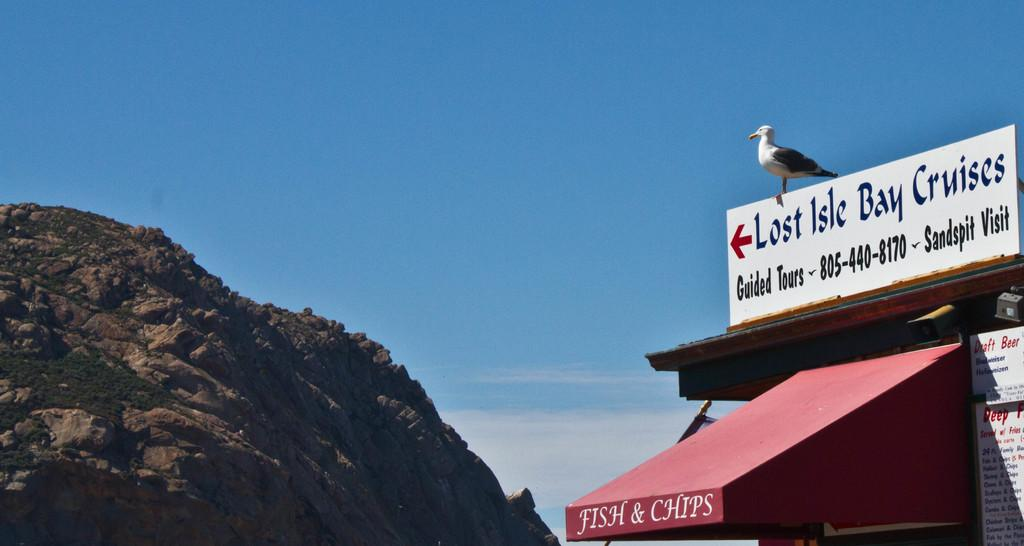Provide a one-sentence caption for the provided image. a locale for fish and chips with a sign on the top that says lost isle bay cruises. 